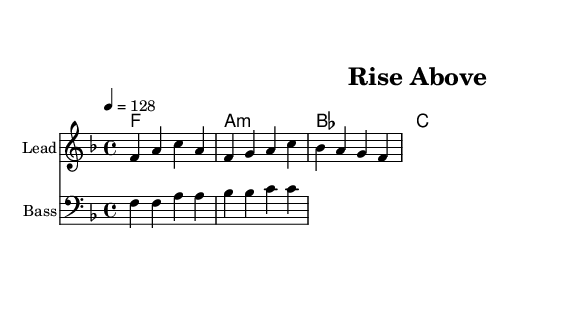What is the key signature of this music? The key signature indicates F major, which has one flat (B flat). This can be identified by looking at the key signature symbol at the beginning of the staff.
Answer: F major What is the time signature used in this piece? The time signature is 4/4, which can be found at the beginning of the score, indicating that there are four beats per measure.
Answer: 4/4 What is the tempo marking for this piece? The tempo marking is 128 beats per minute, which is stated at the beginning of the score as "4 = 128".
Answer: 128 How many measures are in the melody? The melody has a total of 4 measures, which can be counted by looking at the notation and separating each group of notes by the vertical bar lines.
Answer: 4 What is the chord progression shown in this music? The chord progression indicates F, A minor, B flat, and C chords. This is seen in the chord names written above the melody line.
Answer: F A minor B flat C What is the primary mood conveyed by the lyrics in this piece? The lyrics suggest an uplifting and motivational mood, focusing on overcoming challenges as indicated by the opening line "When the world feels heavy and the path unclear."
Answer: Uplifting 